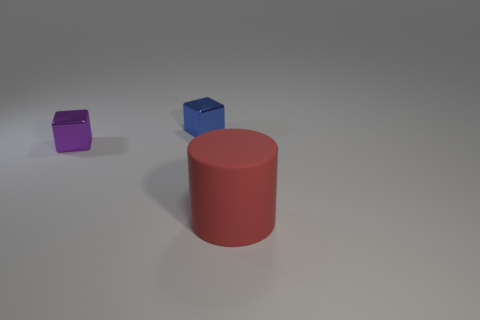What are the shapes and colors of the objects on the left? On the left, there is a small purple cube. Color and shape often play a role in the visual composition, leading to interpretations about balance and contrast within the image. 